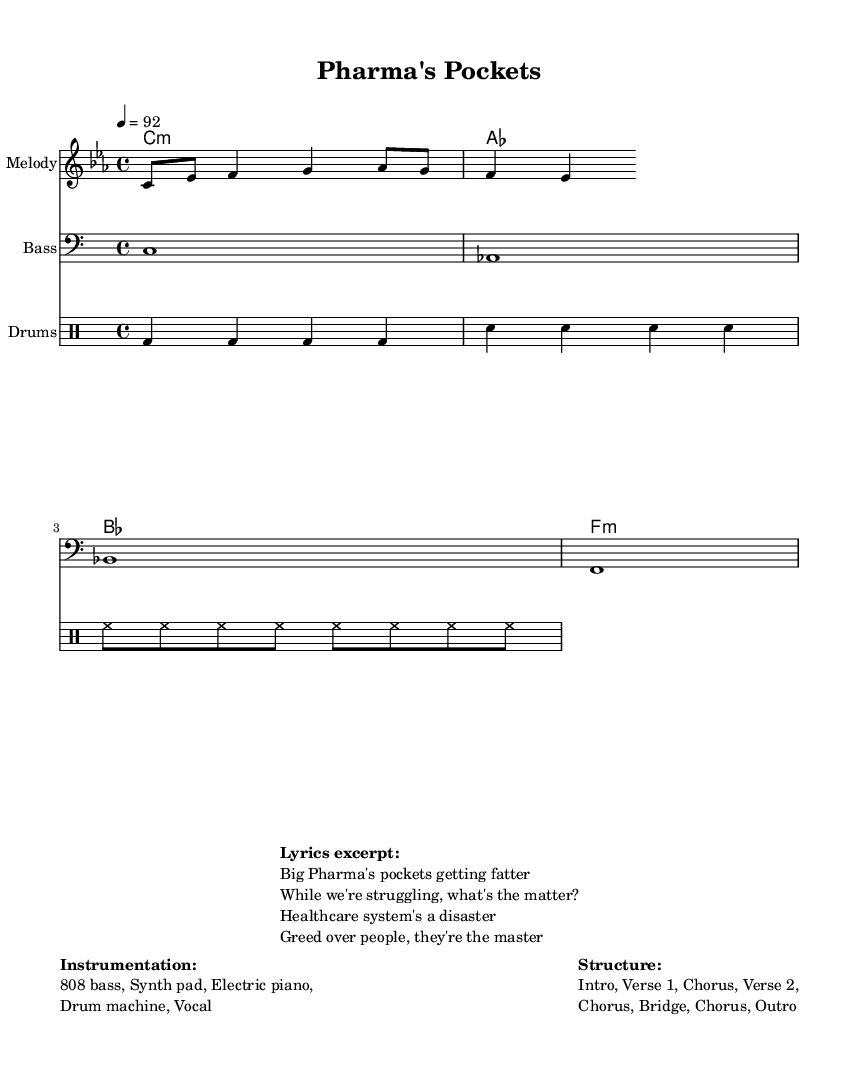What is the key signature of this music? The key signature indicates that it uses C minor, which has three flats (B, E, and A). This can be determined from the global settings at the beginning of the score.
Answer: C minor What is the time signature of this music? The time signature provided in the global settings is 4/4, meaning there are four beats in each measure and a quarter note gets one beat.
Answer: 4/4 What is the tempo of this music? The tempo marking indicates a speed of 92 beats per minute, which is consistent with the pulse of the piece as defined in the global settings.
Answer: 92 What are the main instruments used in this piece? The instrumentation, as described in the markup section, consists of 808 bass, synth pad, electric piano, drum machine, and vocals. This information shows the variety of sounds used in the arrangement.
Answer: 808 bass, Synth pad, Electric piano, Drum machine, Vocal How many sections are in the structure of this piece? The structure outlined in the markup section consists of seven distinct parts: Intro, Verse 1, Chorus, Verse 2, Chorus, Bridge, and Outro, which reflect the traditional format of a popular song.
Answer: Seven What is the lyrical theme of the excerpt provided? The lyrics suggest a theme of criticism towards corporate greed in the healthcare system, highlighting the disparity between the profits of pharmaceutical companies and the struggles of individuals needing care. This conclusion is drawn from the phrases presented in the lyrics excerpt.
Answer: Corporate greed and healthcare crisis What type of chord progression is used here? The harmony section specifies a chord progression: C minor, A major, B flat major, and F minor. This sequence establishes a typical progression in modern hip-hop that supports emotional expression.
Answer: C minor, A major, B flat major, F minor 